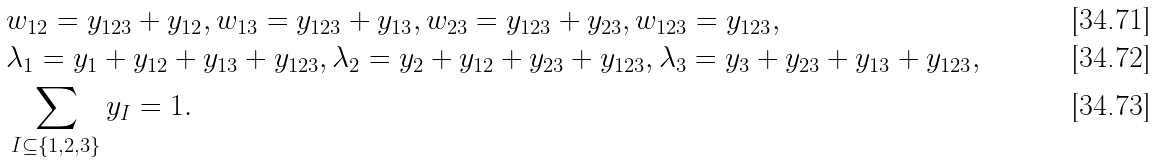<formula> <loc_0><loc_0><loc_500><loc_500>& w _ { 1 2 } = y _ { 1 2 3 } + y _ { 1 2 } , w _ { 1 3 } = y _ { 1 2 3 } + y _ { 1 3 } , w _ { 2 3 } = y _ { 1 2 3 } + y _ { 2 3 } , w _ { 1 2 3 } = y _ { 1 2 3 } , \\ & \lambda _ { 1 } = y _ { 1 } + y _ { 1 2 } + y _ { 1 3 } + y _ { 1 2 3 } , \lambda _ { 2 } = y _ { 2 } + y _ { 1 2 } + y _ { 2 3 } + y _ { 1 2 3 } , \lambda _ { 3 } = y _ { 3 } + y _ { 2 3 } + y _ { 1 3 } + y _ { 1 2 3 } , \\ & \sum _ { I \subseteq \{ 1 , 2 , 3 \} } y _ { I } = 1 .</formula> 